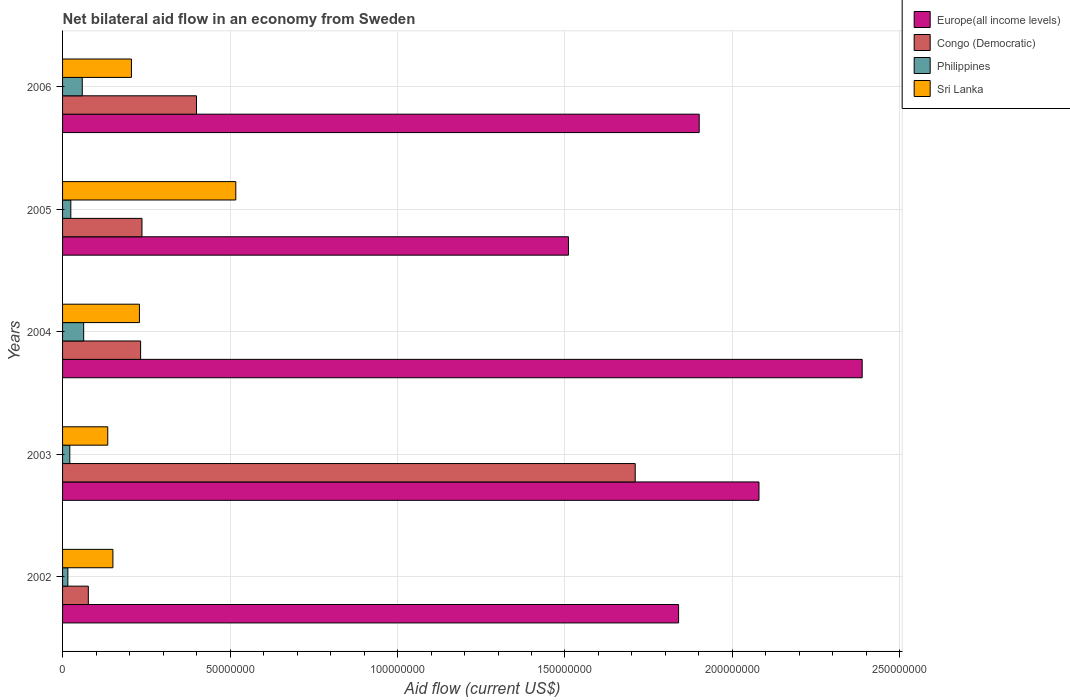How many bars are there on the 3rd tick from the bottom?
Provide a succinct answer. 4. What is the label of the 3rd group of bars from the top?
Give a very brief answer. 2004. In how many cases, is the number of bars for a given year not equal to the number of legend labels?
Your answer should be compact. 0. What is the net bilateral aid flow in Europe(all income levels) in 2003?
Your answer should be very brief. 2.08e+08. Across all years, what is the maximum net bilateral aid flow in Congo (Democratic)?
Provide a succinct answer. 1.71e+08. Across all years, what is the minimum net bilateral aid flow in Philippines?
Make the answer very short. 1.58e+06. What is the total net bilateral aid flow in Philippines in the graph?
Keep it short and to the point. 1.84e+07. What is the difference between the net bilateral aid flow in Sri Lanka in 2002 and that in 2004?
Ensure brevity in your answer.  -7.92e+06. What is the difference between the net bilateral aid flow in Sri Lanka in 2004 and the net bilateral aid flow in Europe(all income levels) in 2006?
Provide a short and direct response. -1.67e+08. What is the average net bilateral aid flow in Europe(all income levels) per year?
Provide a succinct answer. 1.94e+08. In the year 2003, what is the difference between the net bilateral aid flow in Sri Lanka and net bilateral aid flow in Philippines?
Give a very brief answer. 1.13e+07. What is the ratio of the net bilateral aid flow in Philippines in 2003 to that in 2005?
Give a very brief answer. 0.88. Is the difference between the net bilateral aid flow in Sri Lanka in 2002 and 2006 greater than the difference between the net bilateral aid flow in Philippines in 2002 and 2006?
Provide a short and direct response. No. What is the difference between the highest and the second highest net bilateral aid flow in Congo (Democratic)?
Ensure brevity in your answer.  1.31e+08. What is the difference between the highest and the lowest net bilateral aid flow in Europe(all income levels)?
Give a very brief answer. 8.77e+07. In how many years, is the net bilateral aid flow in Philippines greater than the average net bilateral aid flow in Philippines taken over all years?
Offer a very short reply. 2. Is the sum of the net bilateral aid flow in Sri Lanka in 2003 and 2004 greater than the maximum net bilateral aid flow in Europe(all income levels) across all years?
Keep it short and to the point. No. What does the 4th bar from the bottom in 2002 represents?
Ensure brevity in your answer.  Sri Lanka. Is it the case that in every year, the sum of the net bilateral aid flow in Sri Lanka and net bilateral aid flow in Congo (Democratic) is greater than the net bilateral aid flow in Philippines?
Offer a very short reply. Yes. Are all the bars in the graph horizontal?
Your response must be concise. Yes. How many years are there in the graph?
Offer a terse response. 5. Are the values on the major ticks of X-axis written in scientific E-notation?
Ensure brevity in your answer.  No. Where does the legend appear in the graph?
Your answer should be compact. Top right. What is the title of the graph?
Offer a very short reply. Net bilateral aid flow in an economy from Sweden. What is the label or title of the Y-axis?
Provide a succinct answer. Years. What is the Aid flow (current US$) of Europe(all income levels) in 2002?
Your response must be concise. 1.84e+08. What is the Aid flow (current US$) in Congo (Democratic) in 2002?
Offer a terse response. 7.69e+06. What is the Aid flow (current US$) in Philippines in 2002?
Your answer should be very brief. 1.58e+06. What is the Aid flow (current US$) of Sri Lanka in 2002?
Your response must be concise. 1.50e+07. What is the Aid flow (current US$) in Europe(all income levels) in 2003?
Offer a very short reply. 2.08e+08. What is the Aid flow (current US$) in Congo (Democratic) in 2003?
Provide a succinct answer. 1.71e+08. What is the Aid flow (current US$) of Philippines in 2003?
Your answer should be very brief. 2.16e+06. What is the Aid flow (current US$) in Sri Lanka in 2003?
Offer a terse response. 1.35e+07. What is the Aid flow (current US$) in Europe(all income levels) in 2004?
Ensure brevity in your answer.  2.39e+08. What is the Aid flow (current US$) in Congo (Democratic) in 2004?
Give a very brief answer. 2.33e+07. What is the Aid flow (current US$) in Philippines in 2004?
Keep it short and to the point. 6.30e+06. What is the Aid flow (current US$) of Sri Lanka in 2004?
Offer a very short reply. 2.30e+07. What is the Aid flow (current US$) in Europe(all income levels) in 2005?
Give a very brief answer. 1.51e+08. What is the Aid flow (current US$) in Congo (Democratic) in 2005?
Ensure brevity in your answer.  2.37e+07. What is the Aid flow (current US$) in Philippines in 2005?
Keep it short and to the point. 2.46e+06. What is the Aid flow (current US$) of Sri Lanka in 2005?
Your answer should be compact. 5.17e+07. What is the Aid flow (current US$) of Europe(all income levels) in 2006?
Offer a terse response. 1.90e+08. What is the Aid flow (current US$) of Congo (Democratic) in 2006?
Provide a short and direct response. 4.00e+07. What is the Aid flow (current US$) of Philippines in 2006?
Ensure brevity in your answer.  5.88e+06. What is the Aid flow (current US$) of Sri Lanka in 2006?
Provide a short and direct response. 2.06e+07. Across all years, what is the maximum Aid flow (current US$) in Europe(all income levels)?
Give a very brief answer. 2.39e+08. Across all years, what is the maximum Aid flow (current US$) in Congo (Democratic)?
Offer a terse response. 1.71e+08. Across all years, what is the maximum Aid flow (current US$) of Philippines?
Ensure brevity in your answer.  6.30e+06. Across all years, what is the maximum Aid flow (current US$) in Sri Lanka?
Offer a very short reply. 5.17e+07. Across all years, what is the minimum Aid flow (current US$) in Europe(all income levels)?
Keep it short and to the point. 1.51e+08. Across all years, what is the minimum Aid flow (current US$) of Congo (Democratic)?
Make the answer very short. 7.69e+06. Across all years, what is the minimum Aid flow (current US$) in Philippines?
Give a very brief answer. 1.58e+06. Across all years, what is the minimum Aid flow (current US$) in Sri Lanka?
Give a very brief answer. 1.35e+07. What is the total Aid flow (current US$) in Europe(all income levels) in the graph?
Ensure brevity in your answer.  9.72e+08. What is the total Aid flow (current US$) of Congo (Democratic) in the graph?
Your answer should be very brief. 2.66e+08. What is the total Aid flow (current US$) of Philippines in the graph?
Your answer should be very brief. 1.84e+07. What is the total Aid flow (current US$) of Sri Lanka in the graph?
Provide a short and direct response. 1.24e+08. What is the difference between the Aid flow (current US$) of Europe(all income levels) in 2002 and that in 2003?
Provide a short and direct response. -2.40e+07. What is the difference between the Aid flow (current US$) of Congo (Democratic) in 2002 and that in 2003?
Ensure brevity in your answer.  -1.63e+08. What is the difference between the Aid flow (current US$) of Philippines in 2002 and that in 2003?
Your response must be concise. -5.80e+05. What is the difference between the Aid flow (current US$) of Sri Lanka in 2002 and that in 2003?
Provide a succinct answer. 1.54e+06. What is the difference between the Aid flow (current US$) of Europe(all income levels) in 2002 and that in 2004?
Keep it short and to the point. -5.48e+07. What is the difference between the Aid flow (current US$) of Congo (Democratic) in 2002 and that in 2004?
Provide a succinct answer. -1.56e+07. What is the difference between the Aid flow (current US$) of Philippines in 2002 and that in 2004?
Ensure brevity in your answer.  -4.72e+06. What is the difference between the Aid flow (current US$) of Sri Lanka in 2002 and that in 2004?
Keep it short and to the point. -7.92e+06. What is the difference between the Aid flow (current US$) of Europe(all income levels) in 2002 and that in 2005?
Give a very brief answer. 3.29e+07. What is the difference between the Aid flow (current US$) of Congo (Democratic) in 2002 and that in 2005?
Keep it short and to the point. -1.60e+07. What is the difference between the Aid flow (current US$) of Philippines in 2002 and that in 2005?
Provide a succinct answer. -8.80e+05. What is the difference between the Aid flow (current US$) of Sri Lanka in 2002 and that in 2005?
Keep it short and to the point. -3.67e+07. What is the difference between the Aid flow (current US$) in Europe(all income levels) in 2002 and that in 2006?
Your response must be concise. -6.15e+06. What is the difference between the Aid flow (current US$) of Congo (Democratic) in 2002 and that in 2006?
Keep it short and to the point. -3.23e+07. What is the difference between the Aid flow (current US$) of Philippines in 2002 and that in 2006?
Ensure brevity in your answer.  -4.30e+06. What is the difference between the Aid flow (current US$) of Sri Lanka in 2002 and that in 2006?
Provide a short and direct response. -5.53e+06. What is the difference between the Aid flow (current US$) in Europe(all income levels) in 2003 and that in 2004?
Make the answer very short. -3.08e+07. What is the difference between the Aid flow (current US$) in Congo (Democratic) in 2003 and that in 2004?
Make the answer very short. 1.48e+08. What is the difference between the Aid flow (current US$) of Philippines in 2003 and that in 2004?
Keep it short and to the point. -4.14e+06. What is the difference between the Aid flow (current US$) in Sri Lanka in 2003 and that in 2004?
Ensure brevity in your answer.  -9.46e+06. What is the difference between the Aid flow (current US$) in Europe(all income levels) in 2003 and that in 2005?
Keep it short and to the point. 5.69e+07. What is the difference between the Aid flow (current US$) of Congo (Democratic) in 2003 and that in 2005?
Give a very brief answer. 1.47e+08. What is the difference between the Aid flow (current US$) of Philippines in 2003 and that in 2005?
Your answer should be compact. -3.00e+05. What is the difference between the Aid flow (current US$) of Sri Lanka in 2003 and that in 2005?
Give a very brief answer. -3.82e+07. What is the difference between the Aid flow (current US$) of Europe(all income levels) in 2003 and that in 2006?
Your response must be concise. 1.78e+07. What is the difference between the Aid flow (current US$) of Congo (Democratic) in 2003 and that in 2006?
Ensure brevity in your answer.  1.31e+08. What is the difference between the Aid flow (current US$) of Philippines in 2003 and that in 2006?
Ensure brevity in your answer.  -3.72e+06. What is the difference between the Aid flow (current US$) in Sri Lanka in 2003 and that in 2006?
Provide a succinct answer. -7.07e+06. What is the difference between the Aid flow (current US$) in Europe(all income levels) in 2004 and that in 2005?
Provide a short and direct response. 8.77e+07. What is the difference between the Aid flow (current US$) of Congo (Democratic) in 2004 and that in 2005?
Keep it short and to the point. -4.10e+05. What is the difference between the Aid flow (current US$) of Philippines in 2004 and that in 2005?
Ensure brevity in your answer.  3.84e+06. What is the difference between the Aid flow (current US$) of Sri Lanka in 2004 and that in 2005?
Give a very brief answer. -2.88e+07. What is the difference between the Aid flow (current US$) of Europe(all income levels) in 2004 and that in 2006?
Offer a terse response. 4.87e+07. What is the difference between the Aid flow (current US$) in Congo (Democratic) in 2004 and that in 2006?
Offer a terse response. -1.67e+07. What is the difference between the Aid flow (current US$) in Philippines in 2004 and that in 2006?
Offer a terse response. 4.20e+05. What is the difference between the Aid flow (current US$) in Sri Lanka in 2004 and that in 2006?
Your response must be concise. 2.39e+06. What is the difference between the Aid flow (current US$) in Europe(all income levels) in 2005 and that in 2006?
Make the answer very short. -3.90e+07. What is the difference between the Aid flow (current US$) in Congo (Democratic) in 2005 and that in 2006?
Provide a succinct answer. -1.63e+07. What is the difference between the Aid flow (current US$) in Philippines in 2005 and that in 2006?
Provide a short and direct response. -3.42e+06. What is the difference between the Aid flow (current US$) of Sri Lanka in 2005 and that in 2006?
Provide a succinct answer. 3.12e+07. What is the difference between the Aid flow (current US$) in Europe(all income levels) in 2002 and the Aid flow (current US$) in Congo (Democratic) in 2003?
Offer a very short reply. 1.30e+07. What is the difference between the Aid flow (current US$) in Europe(all income levels) in 2002 and the Aid flow (current US$) in Philippines in 2003?
Your answer should be compact. 1.82e+08. What is the difference between the Aid flow (current US$) in Europe(all income levels) in 2002 and the Aid flow (current US$) in Sri Lanka in 2003?
Your answer should be very brief. 1.70e+08. What is the difference between the Aid flow (current US$) in Congo (Democratic) in 2002 and the Aid flow (current US$) in Philippines in 2003?
Offer a terse response. 5.53e+06. What is the difference between the Aid flow (current US$) of Congo (Democratic) in 2002 and the Aid flow (current US$) of Sri Lanka in 2003?
Make the answer very short. -5.80e+06. What is the difference between the Aid flow (current US$) in Philippines in 2002 and the Aid flow (current US$) in Sri Lanka in 2003?
Keep it short and to the point. -1.19e+07. What is the difference between the Aid flow (current US$) in Europe(all income levels) in 2002 and the Aid flow (current US$) in Congo (Democratic) in 2004?
Your answer should be very brief. 1.61e+08. What is the difference between the Aid flow (current US$) in Europe(all income levels) in 2002 and the Aid flow (current US$) in Philippines in 2004?
Provide a succinct answer. 1.78e+08. What is the difference between the Aid flow (current US$) in Europe(all income levels) in 2002 and the Aid flow (current US$) in Sri Lanka in 2004?
Keep it short and to the point. 1.61e+08. What is the difference between the Aid flow (current US$) in Congo (Democratic) in 2002 and the Aid flow (current US$) in Philippines in 2004?
Offer a very short reply. 1.39e+06. What is the difference between the Aid flow (current US$) of Congo (Democratic) in 2002 and the Aid flow (current US$) of Sri Lanka in 2004?
Provide a succinct answer. -1.53e+07. What is the difference between the Aid flow (current US$) of Philippines in 2002 and the Aid flow (current US$) of Sri Lanka in 2004?
Your answer should be compact. -2.14e+07. What is the difference between the Aid flow (current US$) in Europe(all income levels) in 2002 and the Aid flow (current US$) in Congo (Democratic) in 2005?
Provide a succinct answer. 1.60e+08. What is the difference between the Aid flow (current US$) in Europe(all income levels) in 2002 and the Aid flow (current US$) in Philippines in 2005?
Your response must be concise. 1.81e+08. What is the difference between the Aid flow (current US$) in Europe(all income levels) in 2002 and the Aid flow (current US$) in Sri Lanka in 2005?
Provide a succinct answer. 1.32e+08. What is the difference between the Aid flow (current US$) of Congo (Democratic) in 2002 and the Aid flow (current US$) of Philippines in 2005?
Ensure brevity in your answer.  5.23e+06. What is the difference between the Aid flow (current US$) of Congo (Democratic) in 2002 and the Aid flow (current US$) of Sri Lanka in 2005?
Offer a very short reply. -4.40e+07. What is the difference between the Aid flow (current US$) of Philippines in 2002 and the Aid flow (current US$) of Sri Lanka in 2005?
Ensure brevity in your answer.  -5.01e+07. What is the difference between the Aid flow (current US$) of Europe(all income levels) in 2002 and the Aid flow (current US$) of Congo (Democratic) in 2006?
Keep it short and to the point. 1.44e+08. What is the difference between the Aid flow (current US$) in Europe(all income levels) in 2002 and the Aid flow (current US$) in Philippines in 2006?
Ensure brevity in your answer.  1.78e+08. What is the difference between the Aid flow (current US$) in Europe(all income levels) in 2002 and the Aid flow (current US$) in Sri Lanka in 2006?
Ensure brevity in your answer.  1.63e+08. What is the difference between the Aid flow (current US$) in Congo (Democratic) in 2002 and the Aid flow (current US$) in Philippines in 2006?
Ensure brevity in your answer.  1.81e+06. What is the difference between the Aid flow (current US$) of Congo (Democratic) in 2002 and the Aid flow (current US$) of Sri Lanka in 2006?
Make the answer very short. -1.29e+07. What is the difference between the Aid flow (current US$) in Philippines in 2002 and the Aid flow (current US$) in Sri Lanka in 2006?
Provide a short and direct response. -1.90e+07. What is the difference between the Aid flow (current US$) of Europe(all income levels) in 2003 and the Aid flow (current US$) of Congo (Democratic) in 2004?
Give a very brief answer. 1.85e+08. What is the difference between the Aid flow (current US$) in Europe(all income levels) in 2003 and the Aid flow (current US$) in Philippines in 2004?
Your response must be concise. 2.02e+08. What is the difference between the Aid flow (current US$) in Europe(all income levels) in 2003 and the Aid flow (current US$) in Sri Lanka in 2004?
Make the answer very short. 1.85e+08. What is the difference between the Aid flow (current US$) of Congo (Democratic) in 2003 and the Aid flow (current US$) of Philippines in 2004?
Provide a short and direct response. 1.65e+08. What is the difference between the Aid flow (current US$) in Congo (Democratic) in 2003 and the Aid flow (current US$) in Sri Lanka in 2004?
Ensure brevity in your answer.  1.48e+08. What is the difference between the Aid flow (current US$) of Philippines in 2003 and the Aid flow (current US$) of Sri Lanka in 2004?
Provide a short and direct response. -2.08e+07. What is the difference between the Aid flow (current US$) in Europe(all income levels) in 2003 and the Aid flow (current US$) in Congo (Democratic) in 2005?
Provide a succinct answer. 1.84e+08. What is the difference between the Aid flow (current US$) of Europe(all income levels) in 2003 and the Aid flow (current US$) of Philippines in 2005?
Offer a very short reply. 2.05e+08. What is the difference between the Aid flow (current US$) in Europe(all income levels) in 2003 and the Aid flow (current US$) in Sri Lanka in 2005?
Your answer should be compact. 1.56e+08. What is the difference between the Aid flow (current US$) of Congo (Democratic) in 2003 and the Aid flow (current US$) of Philippines in 2005?
Your answer should be compact. 1.69e+08. What is the difference between the Aid flow (current US$) in Congo (Democratic) in 2003 and the Aid flow (current US$) in Sri Lanka in 2005?
Make the answer very short. 1.19e+08. What is the difference between the Aid flow (current US$) in Philippines in 2003 and the Aid flow (current US$) in Sri Lanka in 2005?
Make the answer very short. -4.96e+07. What is the difference between the Aid flow (current US$) of Europe(all income levels) in 2003 and the Aid flow (current US$) of Congo (Democratic) in 2006?
Make the answer very short. 1.68e+08. What is the difference between the Aid flow (current US$) in Europe(all income levels) in 2003 and the Aid flow (current US$) in Philippines in 2006?
Provide a succinct answer. 2.02e+08. What is the difference between the Aid flow (current US$) of Europe(all income levels) in 2003 and the Aid flow (current US$) of Sri Lanka in 2006?
Ensure brevity in your answer.  1.87e+08. What is the difference between the Aid flow (current US$) in Congo (Democratic) in 2003 and the Aid flow (current US$) in Philippines in 2006?
Your answer should be compact. 1.65e+08. What is the difference between the Aid flow (current US$) in Congo (Democratic) in 2003 and the Aid flow (current US$) in Sri Lanka in 2006?
Give a very brief answer. 1.50e+08. What is the difference between the Aid flow (current US$) in Philippines in 2003 and the Aid flow (current US$) in Sri Lanka in 2006?
Offer a terse response. -1.84e+07. What is the difference between the Aid flow (current US$) of Europe(all income levels) in 2004 and the Aid flow (current US$) of Congo (Democratic) in 2005?
Make the answer very short. 2.15e+08. What is the difference between the Aid flow (current US$) in Europe(all income levels) in 2004 and the Aid flow (current US$) in Philippines in 2005?
Your response must be concise. 2.36e+08. What is the difference between the Aid flow (current US$) in Europe(all income levels) in 2004 and the Aid flow (current US$) in Sri Lanka in 2005?
Provide a succinct answer. 1.87e+08. What is the difference between the Aid flow (current US$) of Congo (Democratic) in 2004 and the Aid flow (current US$) of Philippines in 2005?
Offer a very short reply. 2.08e+07. What is the difference between the Aid flow (current US$) of Congo (Democratic) in 2004 and the Aid flow (current US$) of Sri Lanka in 2005?
Keep it short and to the point. -2.84e+07. What is the difference between the Aid flow (current US$) of Philippines in 2004 and the Aid flow (current US$) of Sri Lanka in 2005?
Make the answer very short. -4.54e+07. What is the difference between the Aid flow (current US$) of Europe(all income levels) in 2004 and the Aid flow (current US$) of Congo (Democratic) in 2006?
Your response must be concise. 1.99e+08. What is the difference between the Aid flow (current US$) of Europe(all income levels) in 2004 and the Aid flow (current US$) of Philippines in 2006?
Offer a very short reply. 2.33e+08. What is the difference between the Aid flow (current US$) in Europe(all income levels) in 2004 and the Aid flow (current US$) in Sri Lanka in 2006?
Give a very brief answer. 2.18e+08. What is the difference between the Aid flow (current US$) in Congo (Democratic) in 2004 and the Aid flow (current US$) in Philippines in 2006?
Ensure brevity in your answer.  1.74e+07. What is the difference between the Aid flow (current US$) of Congo (Democratic) in 2004 and the Aid flow (current US$) of Sri Lanka in 2006?
Your answer should be very brief. 2.74e+06. What is the difference between the Aid flow (current US$) in Philippines in 2004 and the Aid flow (current US$) in Sri Lanka in 2006?
Provide a short and direct response. -1.43e+07. What is the difference between the Aid flow (current US$) in Europe(all income levels) in 2005 and the Aid flow (current US$) in Congo (Democratic) in 2006?
Offer a terse response. 1.11e+08. What is the difference between the Aid flow (current US$) of Europe(all income levels) in 2005 and the Aid flow (current US$) of Philippines in 2006?
Provide a succinct answer. 1.45e+08. What is the difference between the Aid flow (current US$) of Europe(all income levels) in 2005 and the Aid flow (current US$) of Sri Lanka in 2006?
Your answer should be compact. 1.30e+08. What is the difference between the Aid flow (current US$) in Congo (Democratic) in 2005 and the Aid flow (current US$) in Philippines in 2006?
Your response must be concise. 1.78e+07. What is the difference between the Aid flow (current US$) of Congo (Democratic) in 2005 and the Aid flow (current US$) of Sri Lanka in 2006?
Offer a terse response. 3.15e+06. What is the difference between the Aid flow (current US$) of Philippines in 2005 and the Aid flow (current US$) of Sri Lanka in 2006?
Offer a terse response. -1.81e+07. What is the average Aid flow (current US$) in Europe(all income levels) per year?
Your response must be concise. 1.94e+08. What is the average Aid flow (current US$) in Congo (Democratic) per year?
Provide a short and direct response. 5.31e+07. What is the average Aid flow (current US$) of Philippines per year?
Keep it short and to the point. 3.68e+06. What is the average Aid flow (current US$) of Sri Lanka per year?
Make the answer very short. 2.48e+07. In the year 2002, what is the difference between the Aid flow (current US$) of Europe(all income levels) and Aid flow (current US$) of Congo (Democratic)?
Provide a succinct answer. 1.76e+08. In the year 2002, what is the difference between the Aid flow (current US$) in Europe(all income levels) and Aid flow (current US$) in Philippines?
Offer a terse response. 1.82e+08. In the year 2002, what is the difference between the Aid flow (current US$) in Europe(all income levels) and Aid flow (current US$) in Sri Lanka?
Give a very brief answer. 1.69e+08. In the year 2002, what is the difference between the Aid flow (current US$) in Congo (Democratic) and Aid flow (current US$) in Philippines?
Keep it short and to the point. 6.11e+06. In the year 2002, what is the difference between the Aid flow (current US$) in Congo (Democratic) and Aid flow (current US$) in Sri Lanka?
Offer a very short reply. -7.34e+06. In the year 2002, what is the difference between the Aid flow (current US$) of Philippines and Aid flow (current US$) of Sri Lanka?
Offer a terse response. -1.34e+07. In the year 2003, what is the difference between the Aid flow (current US$) of Europe(all income levels) and Aid flow (current US$) of Congo (Democratic)?
Your response must be concise. 3.70e+07. In the year 2003, what is the difference between the Aid flow (current US$) in Europe(all income levels) and Aid flow (current US$) in Philippines?
Provide a short and direct response. 2.06e+08. In the year 2003, what is the difference between the Aid flow (current US$) in Europe(all income levels) and Aid flow (current US$) in Sri Lanka?
Give a very brief answer. 1.94e+08. In the year 2003, what is the difference between the Aid flow (current US$) in Congo (Democratic) and Aid flow (current US$) in Philippines?
Offer a terse response. 1.69e+08. In the year 2003, what is the difference between the Aid flow (current US$) of Congo (Democratic) and Aid flow (current US$) of Sri Lanka?
Your response must be concise. 1.57e+08. In the year 2003, what is the difference between the Aid flow (current US$) in Philippines and Aid flow (current US$) in Sri Lanka?
Make the answer very short. -1.13e+07. In the year 2004, what is the difference between the Aid flow (current US$) of Europe(all income levels) and Aid flow (current US$) of Congo (Democratic)?
Provide a succinct answer. 2.15e+08. In the year 2004, what is the difference between the Aid flow (current US$) of Europe(all income levels) and Aid flow (current US$) of Philippines?
Provide a short and direct response. 2.32e+08. In the year 2004, what is the difference between the Aid flow (current US$) in Europe(all income levels) and Aid flow (current US$) in Sri Lanka?
Give a very brief answer. 2.16e+08. In the year 2004, what is the difference between the Aid flow (current US$) of Congo (Democratic) and Aid flow (current US$) of Philippines?
Your answer should be very brief. 1.70e+07. In the year 2004, what is the difference between the Aid flow (current US$) in Congo (Democratic) and Aid flow (current US$) in Sri Lanka?
Provide a short and direct response. 3.50e+05. In the year 2004, what is the difference between the Aid flow (current US$) in Philippines and Aid flow (current US$) in Sri Lanka?
Offer a very short reply. -1.66e+07. In the year 2005, what is the difference between the Aid flow (current US$) in Europe(all income levels) and Aid flow (current US$) in Congo (Democratic)?
Offer a terse response. 1.27e+08. In the year 2005, what is the difference between the Aid flow (current US$) of Europe(all income levels) and Aid flow (current US$) of Philippines?
Your answer should be very brief. 1.49e+08. In the year 2005, what is the difference between the Aid flow (current US$) of Europe(all income levels) and Aid flow (current US$) of Sri Lanka?
Give a very brief answer. 9.93e+07. In the year 2005, what is the difference between the Aid flow (current US$) of Congo (Democratic) and Aid flow (current US$) of Philippines?
Offer a terse response. 2.12e+07. In the year 2005, what is the difference between the Aid flow (current US$) in Congo (Democratic) and Aid flow (current US$) in Sri Lanka?
Provide a succinct answer. -2.80e+07. In the year 2005, what is the difference between the Aid flow (current US$) in Philippines and Aid flow (current US$) in Sri Lanka?
Offer a terse response. -4.93e+07. In the year 2006, what is the difference between the Aid flow (current US$) in Europe(all income levels) and Aid flow (current US$) in Congo (Democratic)?
Provide a succinct answer. 1.50e+08. In the year 2006, what is the difference between the Aid flow (current US$) in Europe(all income levels) and Aid flow (current US$) in Philippines?
Provide a succinct answer. 1.84e+08. In the year 2006, what is the difference between the Aid flow (current US$) in Europe(all income levels) and Aid flow (current US$) in Sri Lanka?
Your response must be concise. 1.70e+08. In the year 2006, what is the difference between the Aid flow (current US$) in Congo (Democratic) and Aid flow (current US$) in Philippines?
Give a very brief answer. 3.41e+07. In the year 2006, what is the difference between the Aid flow (current US$) of Congo (Democratic) and Aid flow (current US$) of Sri Lanka?
Make the answer very short. 1.94e+07. In the year 2006, what is the difference between the Aid flow (current US$) in Philippines and Aid flow (current US$) in Sri Lanka?
Offer a terse response. -1.47e+07. What is the ratio of the Aid flow (current US$) in Europe(all income levels) in 2002 to that in 2003?
Make the answer very short. 0.88. What is the ratio of the Aid flow (current US$) in Congo (Democratic) in 2002 to that in 2003?
Your response must be concise. 0.04. What is the ratio of the Aid flow (current US$) in Philippines in 2002 to that in 2003?
Provide a short and direct response. 0.73. What is the ratio of the Aid flow (current US$) of Sri Lanka in 2002 to that in 2003?
Keep it short and to the point. 1.11. What is the ratio of the Aid flow (current US$) in Europe(all income levels) in 2002 to that in 2004?
Your answer should be compact. 0.77. What is the ratio of the Aid flow (current US$) in Congo (Democratic) in 2002 to that in 2004?
Provide a succinct answer. 0.33. What is the ratio of the Aid flow (current US$) of Philippines in 2002 to that in 2004?
Offer a terse response. 0.25. What is the ratio of the Aid flow (current US$) of Sri Lanka in 2002 to that in 2004?
Your answer should be very brief. 0.65. What is the ratio of the Aid flow (current US$) of Europe(all income levels) in 2002 to that in 2005?
Your answer should be compact. 1.22. What is the ratio of the Aid flow (current US$) in Congo (Democratic) in 2002 to that in 2005?
Keep it short and to the point. 0.32. What is the ratio of the Aid flow (current US$) of Philippines in 2002 to that in 2005?
Give a very brief answer. 0.64. What is the ratio of the Aid flow (current US$) of Sri Lanka in 2002 to that in 2005?
Offer a terse response. 0.29. What is the ratio of the Aid flow (current US$) in Europe(all income levels) in 2002 to that in 2006?
Your response must be concise. 0.97. What is the ratio of the Aid flow (current US$) of Congo (Democratic) in 2002 to that in 2006?
Your response must be concise. 0.19. What is the ratio of the Aid flow (current US$) of Philippines in 2002 to that in 2006?
Your answer should be very brief. 0.27. What is the ratio of the Aid flow (current US$) in Sri Lanka in 2002 to that in 2006?
Offer a very short reply. 0.73. What is the ratio of the Aid flow (current US$) in Europe(all income levels) in 2003 to that in 2004?
Keep it short and to the point. 0.87. What is the ratio of the Aid flow (current US$) in Congo (Democratic) in 2003 to that in 2004?
Offer a very short reply. 7.34. What is the ratio of the Aid flow (current US$) of Philippines in 2003 to that in 2004?
Your answer should be very brief. 0.34. What is the ratio of the Aid flow (current US$) of Sri Lanka in 2003 to that in 2004?
Offer a very short reply. 0.59. What is the ratio of the Aid flow (current US$) of Europe(all income levels) in 2003 to that in 2005?
Offer a very short reply. 1.38. What is the ratio of the Aid flow (current US$) in Congo (Democratic) in 2003 to that in 2005?
Give a very brief answer. 7.21. What is the ratio of the Aid flow (current US$) in Philippines in 2003 to that in 2005?
Offer a terse response. 0.88. What is the ratio of the Aid flow (current US$) in Sri Lanka in 2003 to that in 2005?
Provide a short and direct response. 0.26. What is the ratio of the Aid flow (current US$) of Europe(all income levels) in 2003 to that in 2006?
Your answer should be compact. 1.09. What is the ratio of the Aid flow (current US$) in Congo (Democratic) in 2003 to that in 2006?
Give a very brief answer. 4.28. What is the ratio of the Aid flow (current US$) in Philippines in 2003 to that in 2006?
Offer a terse response. 0.37. What is the ratio of the Aid flow (current US$) in Sri Lanka in 2003 to that in 2006?
Offer a terse response. 0.66. What is the ratio of the Aid flow (current US$) of Europe(all income levels) in 2004 to that in 2005?
Keep it short and to the point. 1.58. What is the ratio of the Aid flow (current US$) in Congo (Democratic) in 2004 to that in 2005?
Keep it short and to the point. 0.98. What is the ratio of the Aid flow (current US$) of Philippines in 2004 to that in 2005?
Your response must be concise. 2.56. What is the ratio of the Aid flow (current US$) of Sri Lanka in 2004 to that in 2005?
Keep it short and to the point. 0.44. What is the ratio of the Aid flow (current US$) in Europe(all income levels) in 2004 to that in 2006?
Provide a succinct answer. 1.26. What is the ratio of the Aid flow (current US$) in Congo (Democratic) in 2004 to that in 2006?
Provide a succinct answer. 0.58. What is the ratio of the Aid flow (current US$) of Philippines in 2004 to that in 2006?
Offer a terse response. 1.07. What is the ratio of the Aid flow (current US$) of Sri Lanka in 2004 to that in 2006?
Your answer should be compact. 1.12. What is the ratio of the Aid flow (current US$) of Europe(all income levels) in 2005 to that in 2006?
Your answer should be very brief. 0.79. What is the ratio of the Aid flow (current US$) of Congo (Democratic) in 2005 to that in 2006?
Make the answer very short. 0.59. What is the ratio of the Aid flow (current US$) in Philippines in 2005 to that in 2006?
Your answer should be very brief. 0.42. What is the ratio of the Aid flow (current US$) of Sri Lanka in 2005 to that in 2006?
Your response must be concise. 2.52. What is the difference between the highest and the second highest Aid flow (current US$) of Europe(all income levels)?
Your response must be concise. 3.08e+07. What is the difference between the highest and the second highest Aid flow (current US$) of Congo (Democratic)?
Make the answer very short. 1.31e+08. What is the difference between the highest and the second highest Aid flow (current US$) of Philippines?
Ensure brevity in your answer.  4.20e+05. What is the difference between the highest and the second highest Aid flow (current US$) in Sri Lanka?
Offer a terse response. 2.88e+07. What is the difference between the highest and the lowest Aid flow (current US$) of Europe(all income levels)?
Your answer should be compact. 8.77e+07. What is the difference between the highest and the lowest Aid flow (current US$) of Congo (Democratic)?
Offer a terse response. 1.63e+08. What is the difference between the highest and the lowest Aid flow (current US$) in Philippines?
Make the answer very short. 4.72e+06. What is the difference between the highest and the lowest Aid flow (current US$) in Sri Lanka?
Give a very brief answer. 3.82e+07. 